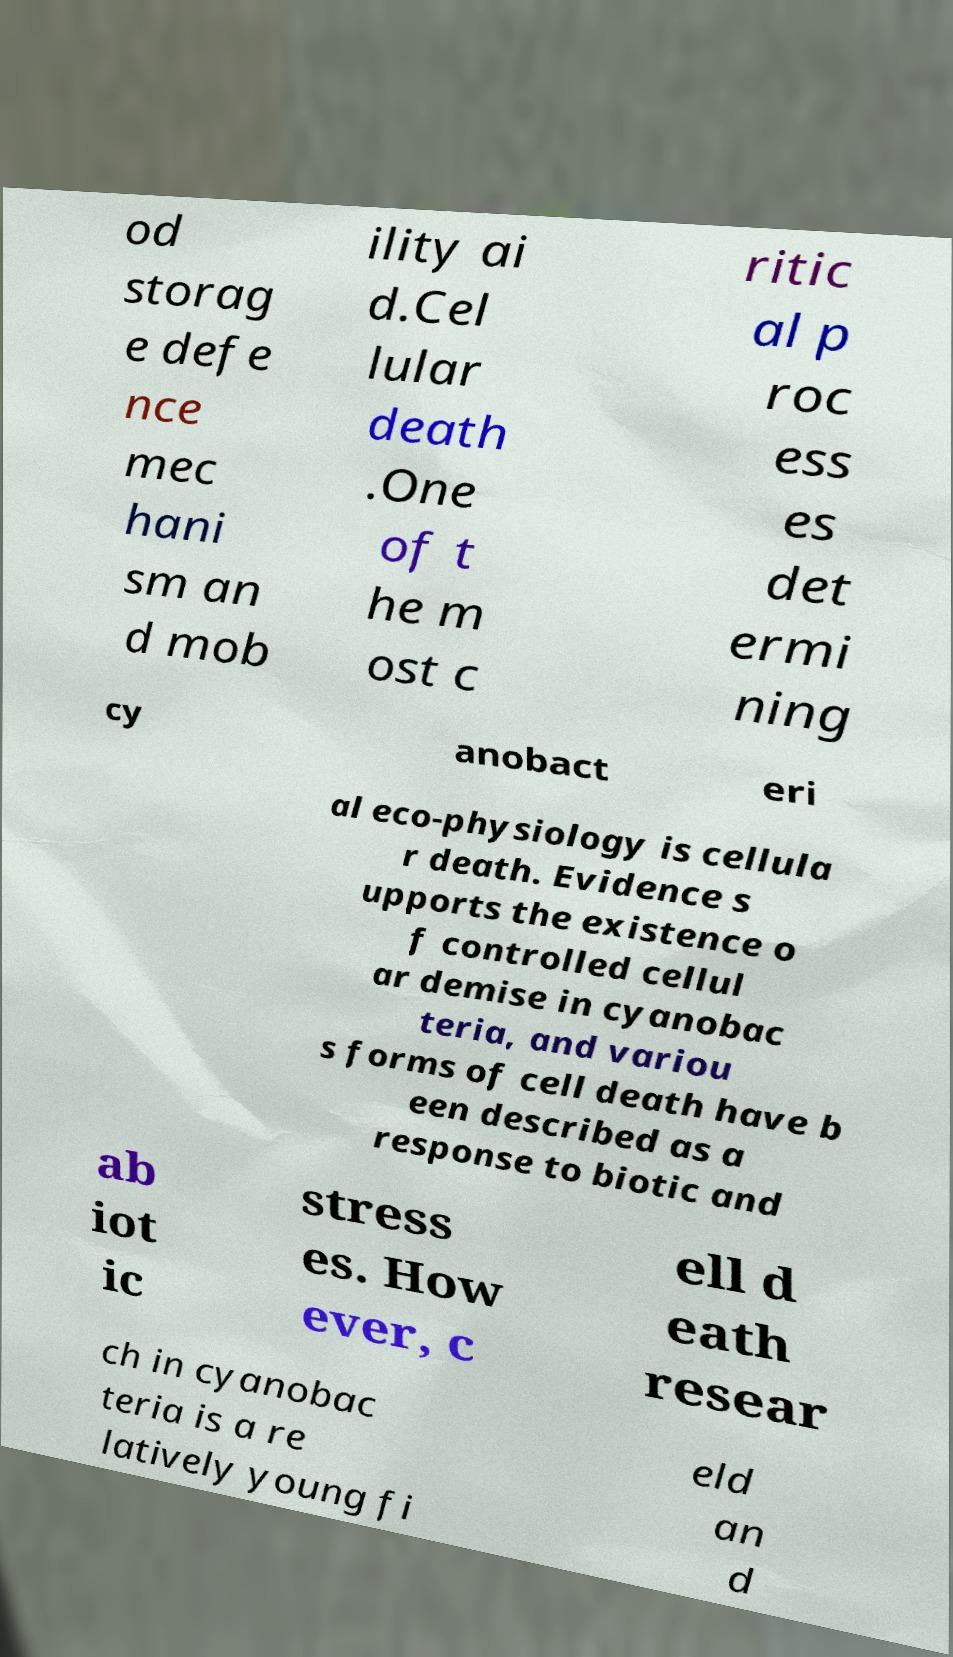Can you read and provide the text displayed in the image?This photo seems to have some interesting text. Can you extract and type it out for me? od storag e defe nce mec hani sm an d mob ility ai d.Cel lular death .One of t he m ost c ritic al p roc ess es det ermi ning cy anobact eri al eco-physiology is cellula r death. Evidence s upports the existence o f controlled cellul ar demise in cyanobac teria, and variou s forms of cell death have b een described as a response to biotic and ab iot ic stress es. How ever, c ell d eath resear ch in cyanobac teria is a re latively young fi eld an d 